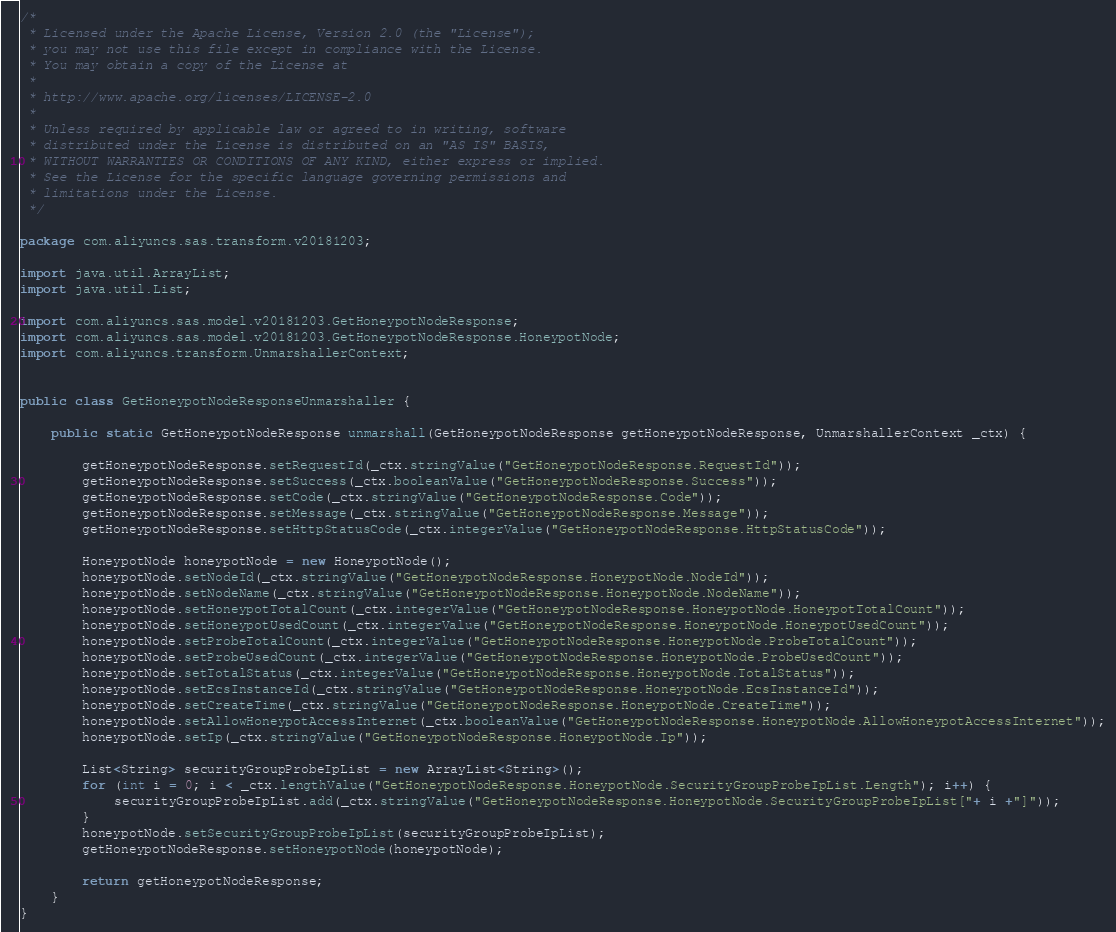Convert code to text. <code><loc_0><loc_0><loc_500><loc_500><_Java_>/*
 * Licensed under the Apache License, Version 2.0 (the "License");
 * you may not use this file except in compliance with the License.
 * You may obtain a copy of the License at
 *
 * http://www.apache.org/licenses/LICENSE-2.0
 *
 * Unless required by applicable law or agreed to in writing, software
 * distributed under the License is distributed on an "AS IS" BASIS,
 * WITHOUT WARRANTIES OR CONDITIONS OF ANY KIND, either express or implied.
 * See the License for the specific language governing permissions and
 * limitations under the License.
 */

package com.aliyuncs.sas.transform.v20181203;

import java.util.ArrayList;
import java.util.List;

import com.aliyuncs.sas.model.v20181203.GetHoneypotNodeResponse;
import com.aliyuncs.sas.model.v20181203.GetHoneypotNodeResponse.HoneypotNode;
import com.aliyuncs.transform.UnmarshallerContext;


public class GetHoneypotNodeResponseUnmarshaller {

	public static GetHoneypotNodeResponse unmarshall(GetHoneypotNodeResponse getHoneypotNodeResponse, UnmarshallerContext _ctx) {
		
		getHoneypotNodeResponse.setRequestId(_ctx.stringValue("GetHoneypotNodeResponse.RequestId"));
		getHoneypotNodeResponse.setSuccess(_ctx.booleanValue("GetHoneypotNodeResponse.Success"));
		getHoneypotNodeResponse.setCode(_ctx.stringValue("GetHoneypotNodeResponse.Code"));
		getHoneypotNodeResponse.setMessage(_ctx.stringValue("GetHoneypotNodeResponse.Message"));
		getHoneypotNodeResponse.setHttpStatusCode(_ctx.integerValue("GetHoneypotNodeResponse.HttpStatusCode"));

		HoneypotNode honeypotNode = new HoneypotNode();
		honeypotNode.setNodeId(_ctx.stringValue("GetHoneypotNodeResponse.HoneypotNode.NodeId"));
		honeypotNode.setNodeName(_ctx.stringValue("GetHoneypotNodeResponse.HoneypotNode.NodeName"));
		honeypotNode.setHoneypotTotalCount(_ctx.integerValue("GetHoneypotNodeResponse.HoneypotNode.HoneypotTotalCount"));
		honeypotNode.setHoneypotUsedCount(_ctx.integerValue("GetHoneypotNodeResponse.HoneypotNode.HoneypotUsedCount"));
		honeypotNode.setProbeTotalCount(_ctx.integerValue("GetHoneypotNodeResponse.HoneypotNode.ProbeTotalCount"));
		honeypotNode.setProbeUsedCount(_ctx.integerValue("GetHoneypotNodeResponse.HoneypotNode.ProbeUsedCount"));
		honeypotNode.setTotalStatus(_ctx.integerValue("GetHoneypotNodeResponse.HoneypotNode.TotalStatus"));
		honeypotNode.setEcsInstanceId(_ctx.stringValue("GetHoneypotNodeResponse.HoneypotNode.EcsInstanceId"));
		honeypotNode.setCreateTime(_ctx.stringValue("GetHoneypotNodeResponse.HoneypotNode.CreateTime"));
		honeypotNode.setAllowHoneypotAccessInternet(_ctx.booleanValue("GetHoneypotNodeResponse.HoneypotNode.AllowHoneypotAccessInternet"));
		honeypotNode.setIp(_ctx.stringValue("GetHoneypotNodeResponse.HoneypotNode.Ip"));

		List<String> securityGroupProbeIpList = new ArrayList<String>();
		for (int i = 0; i < _ctx.lengthValue("GetHoneypotNodeResponse.HoneypotNode.SecurityGroupProbeIpList.Length"); i++) {
			securityGroupProbeIpList.add(_ctx.stringValue("GetHoneypotNodeResponse.HoneypotNode.SecurityGroupProbeIpList["+ i +"]"));
		}
		honeypotNode.setSecurityGroupProbeIpList(securityGroupProbeIpList);
		getHoneypotNodeResponse.setHoneypotNode(honeypotNode);
	 
	 	return getHoneypotNodeResponse;
	}
}</code> 